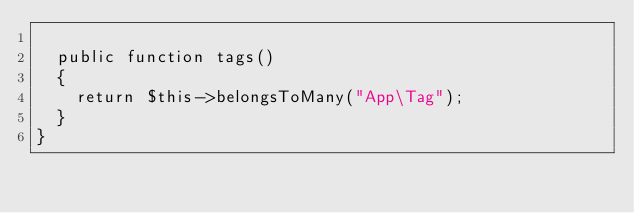<code> <loc_0><loc_0><loc_500><loc_500><_PHP_>
  public function tags()
  {
    return $this->belongsToMany("App\Tag");
  }
}
</code> 